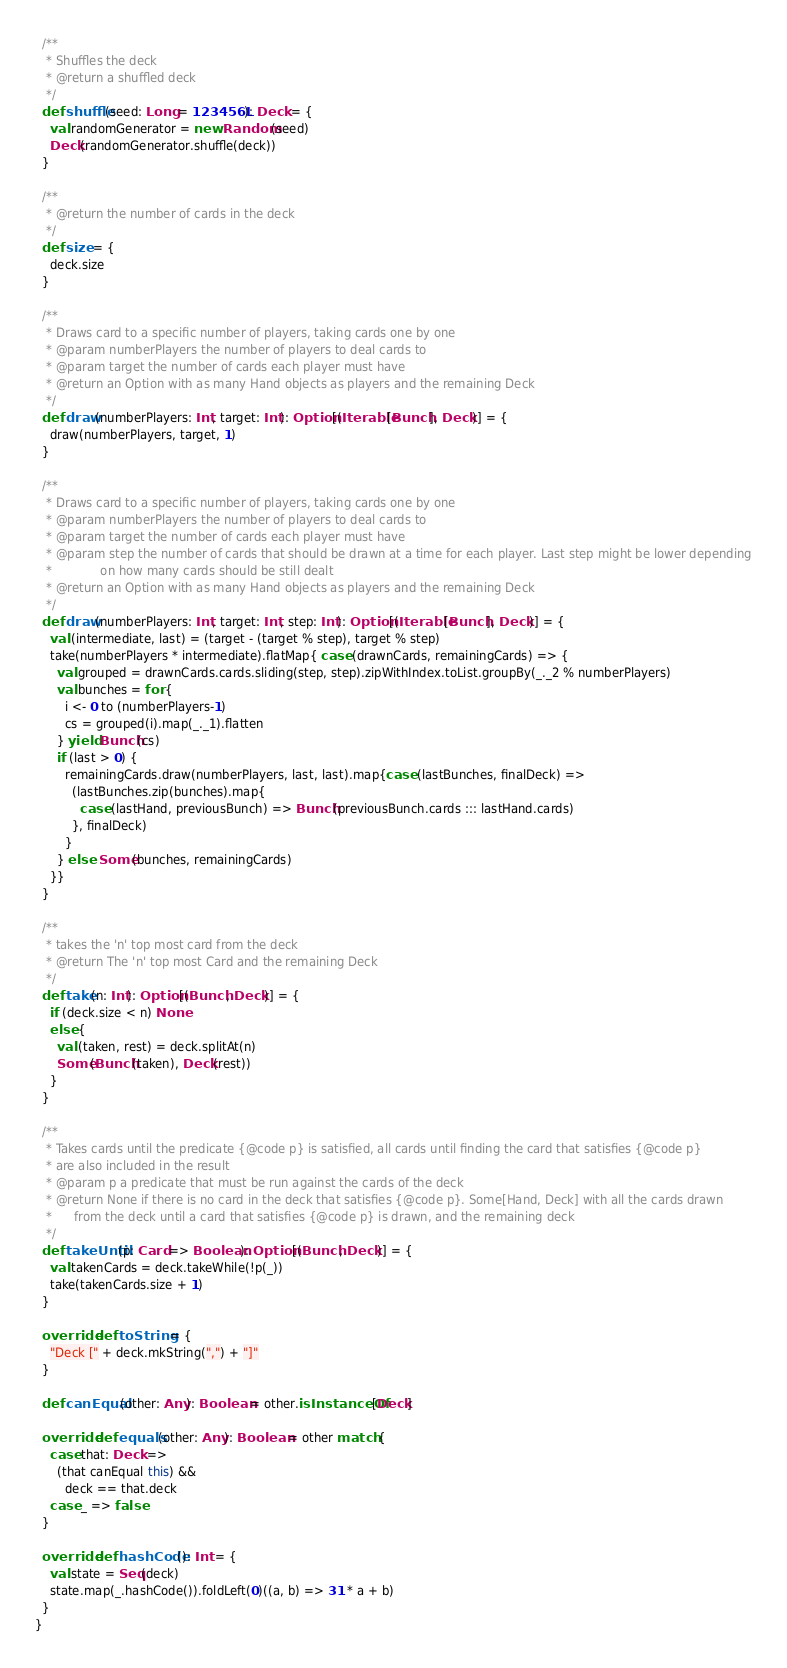Convert code to text. <code><loc_0><loc_0><loc_500><loc_500><_Scala_>
  /**
   * Shuffles the deck
   * @return a shuffled deck
   */
  def shuffle(seed: Long = 123456L): Deck = {
    val randomGenerator = new Random(seed)
    Deck(randomGenerator.shuffle(deck))
  }

  /**
   * @return the number of cards in the deck
   */
  def size = {
    deck.size
  }

  /**
   * Draws card to a specific number of players, taking cards one by one
   * @param numberPlayers the number of players to deal cards to
   * @param target the number of cards each player must have
   * @return an Option with as many Hand objects as players and the remaining Deck
   */
  def draw(numberPlayers: Int, target: Int): Option[(Iterable[Bunch], Deck)] = {
    draw(numberPlayers, target, 1)
  }

  /**
   * Draws card to a specific number of players, taking cards one by one
   * @param numberPlayers the number of players to deal cards to
   * @param target the number of cards each player must have
   * @param step the number of cards that should be drawn at a time for each player. Last step might be lower depending
   *             on how many cards should be still dealt
   * @return an Option with as many Hand objects as players and the remaining Deck
   */
  def draw(numberPlayers: Int, target: Int, step: Int): Option[(Iterable[Bunch], Deck)] = {
    val (intermediate, last) = (target - (target % step), target % step)
    take(numberPlayers * intermediate).flatMap{ case (drawnCards, remainingCards) => {
      val grouped = drawnCards.cards.sliding(step, step).zipWithIndex.toList.groupBy(_._2 % numberPlayers)
      val bunches = for {
        i <- 0 to (numberPlayers-1)
        cs = grouped(i).map(_._1).flatten
      } yield Bunch(cs)
      if (last > 0) {
        remainingCards.draw(numberPlayers, last, last).map{case (lastBunches, finalDeck) =>
          (lastBunches.zip(bunches).map{
            case (lastHand, previousBunch) => Bunch(previousBunch.cards ::: lastHand.cards)
          }, finalDeck)
        }
      } else  Some(bunches, remainingCards)
    }}
  }

  /**
   * takes the 'n' top most card from the deck
   * @return The 'n' top most Card and the remaining Deck
   */
  def take(n: Int): Option[(Bunch, Deck)] = {
    if (deck.size < n) None
    else {
      val (taken, rest) = deck.splitAt(n)
      Some(Bunch(taken), Deck(rest))
    }
  }

  /**
   * Takes cards until the predicate {@code p} is satisfied, all cards until finding the card that satisfies {@code p}
   * are also included in the result
   * @param p a predicate that must be run against the cards of the deck
   * @return None if there is no card in the deck that satisfies {@code p}. Some[Hand, Deck] with all the cards drawn
   *      from the deck until a card that satisfies {@code p} is drawn, and the remaining deck
   */
  def takeUntil(p: Card => Boolean): Option[(Bunch, Deck)] = {
    val takenCards = deck.takeWhile(!p(_))
    take(takenCards.size + 1)
  }

  override def toString = {
    "Deck [" + deck.mkString(",") + "]"
  }

  def canEqual(other: Any): Boolean = other.isInstanceOf[Deck]

  override def equals(other: Any): Boolean = other match {
    case that: Deck =>
      (that canEqual this) &&
        deck == that.deck
    case _ => false
  }

  override def hashCode(): Int = {
    val state = Seq(deck)
    state.map(_.hashCode()).foldLeft(0)((a, b) => 31 * a + b)
  }
}
</code> 